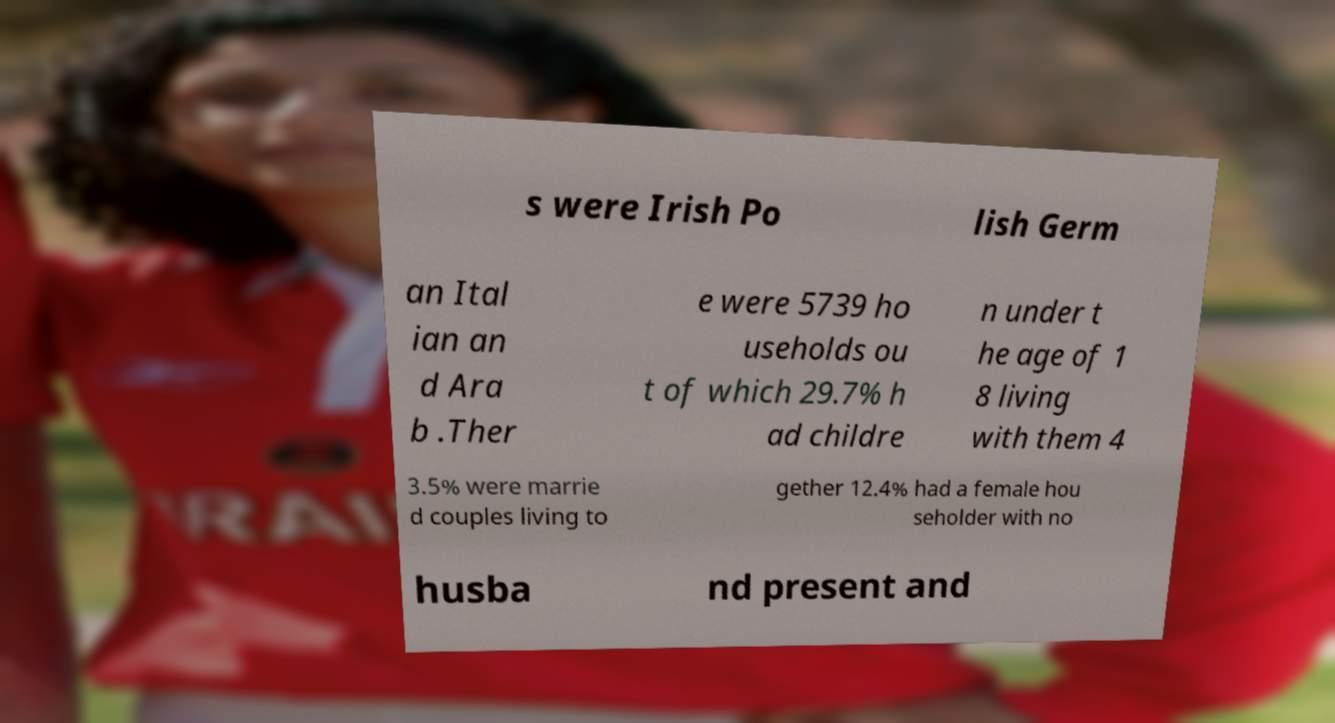I need the written content from this picture converted into text. Can you do that? s were Irish Po lish Germ an Ital ian an d Ara b .Ther e were 5739 ho useholds ou t of which 29.7% h ad childre n under t he age of 1 8 living with them 4 3.5% were marrie d couples living to gether 12.4% had a female hou seholder with no husba nd present and 